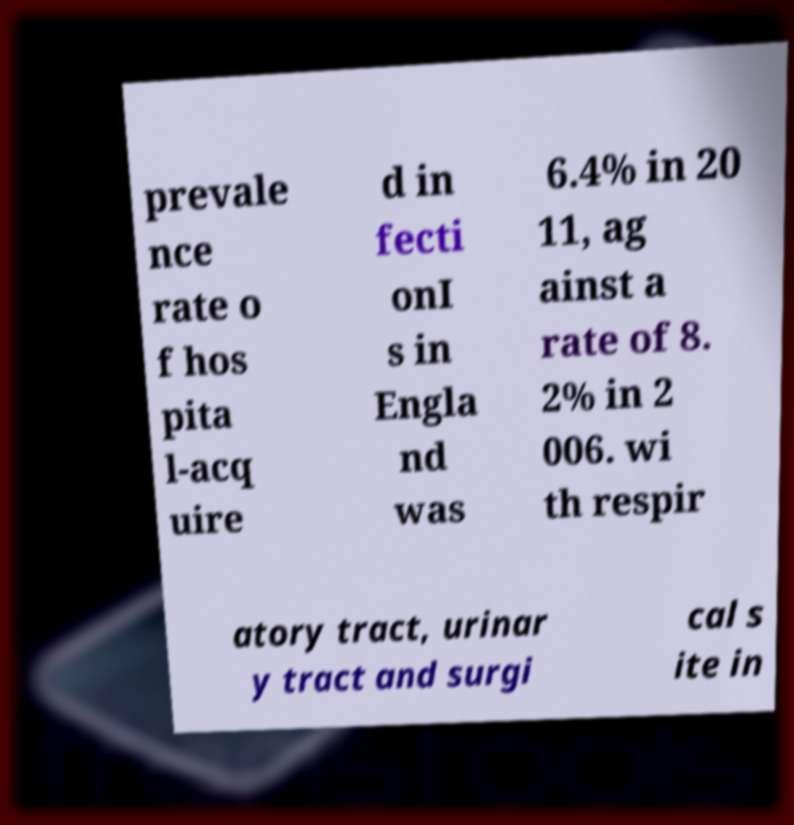Can you accurately transcribe the text from the provided image for me? prevale nce rate o f hos pita l-acq uire d in fecti onI s in Engla nd was 6.4% in 20 11, ag ainst a rate of 8. 2% in 2 006. wi th respir atory tract, urinar y tract and surgi cal s ite in 